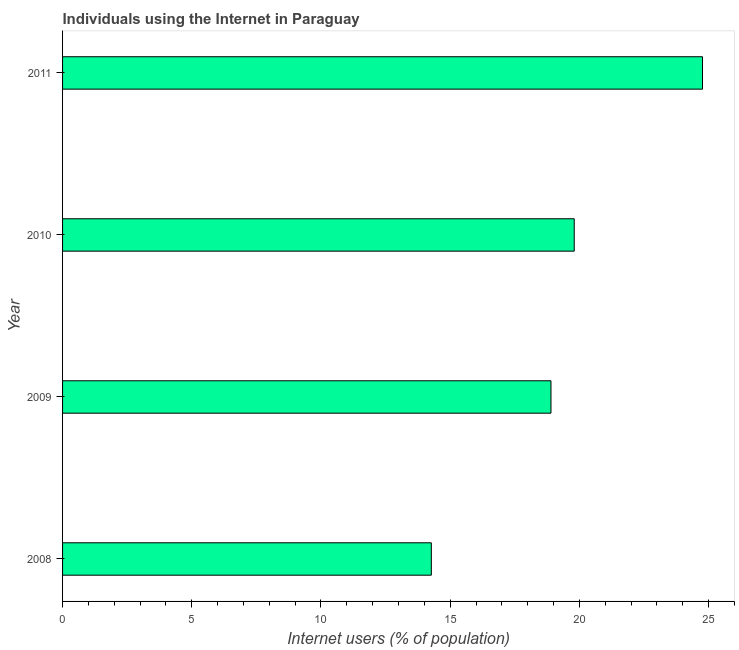What is the title of the graph?
Provide a succinct answer. Individuals using the Internet in Paraguay. What is the label or title of the X-axis?
Offer a terse response. Internet users (% of population). What is the number of internet users in 2008?
Provide a succinct answer. 14.27. Across all years, what is the maximum number of internet users?
Offer a terse response. 24.76. Across all years, what is the minimum number of internet users?
Provide a succinct answer. 14.27. In which year was the number of internet users maximum?
Your answer should be very brief. 2011. What is the sum of the number of internet users?
Offer a very short reply. 77.73. What is the difference between the number of internet users in 2008 and 2011?
Make the answer very short. -10.49. What is the average number of internet users per year?
Give a very brief answer. 19.43. What is the median number of internet users?
Ensure brevity in your answer.  19.35. In how many years, is the number of internet users greater than 25 %?
Your answer should be very brief. 0. What is the ratio of the number of internet users in 2008 to that in 2011?
Ensure brevity in your answer.  0.58. What is the difference between the highest and the second highest number of internet users?
Offer a terse response. 4.96. Is the sum of the number of internet users in 2009 and 2010 greater than the maximum number of internet users across all years?
Your answer should be very brief. Yes. What is the difference between the highest and the lowest number of internet users?
Your answer should be compact. 10.49. In how many years, is the number of internet users greater than the average number of internet users taken over all years?
Provide a short and direct response. 2. How many years are there in the graph?
Your answer should be very brief. 4. What is the difference between two consecutive major ticks on the X-axis?
Offer a very short reply. 5. Are the values on the major ticks of X-axis written in scientific E-notation?
Give a very brief answer. No. What is the Internet users (% of population) of 2008?
Provide a succinct answer. 14.27. What is the Internet users (% of population) of 2010?
Offer a terse response. 19.8. What is the Internet users (% of population) in 2011?
Offer a terse response. 24.76. What is the difference between the Internet users (% of population) in 2008 and 2009?
Ensure brevity in your answer.  -4.63. What is the difference between the Internet users (% of population) in 2008 and 2010?
Your answer should be very brief. -5.53. What is the difference between the Internet users (% of population) in 2008 and 2011?
Provide a short and direct response. -10.49. What is the difference between the Internet users (% of population) in 2009 and 2011?
Your response must be concise. -5.86. What is the difference between the Internet users (% of population) in 2010 and 2011?
Keep it short and to the point. -4.96. What is the ratio of the Internet users (% of population) in 2008 to that in 2009?
Your answer should be compact. 0.76. What is the ratio of the Internet users (% of population) in 2008 to that in 2010?
Offer a very short reply. 0.72. What is the ratio of the Internet users (% of population) in 2008 to that in 2011?
Provide a short and direct response. 0.58. What is the ratio of the Internet users (% of population) in 2009 to that in 2010?
Offer a very short reply. 0.95. What is the ratio of the Internet users (% of population) in 2009 to that in 2011?
Offer a very short reply. 0.76. What is the ratio of the Internet users (% of population) in 2010 to that in 2011?
Make the answer very short. 0.8. 